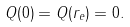<formula> <loc_0><loc_0><loc_500><loc_500>Q ( 0 ) = Q ( r _ { e } ) = 0 .</formula> 